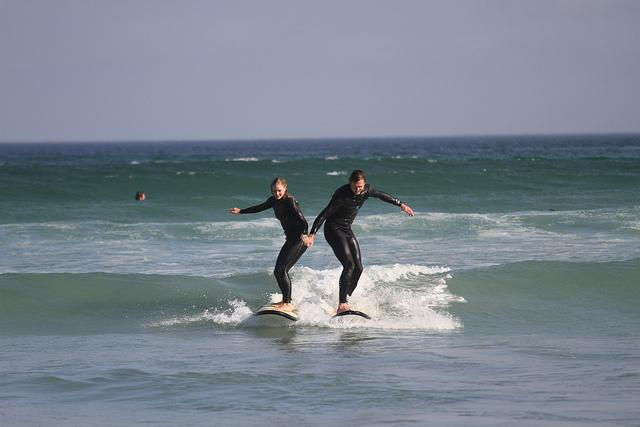How do these people know each other?

Choices:
A) coworkers
B) spouses
C) rivals
D) pen pals spouses 